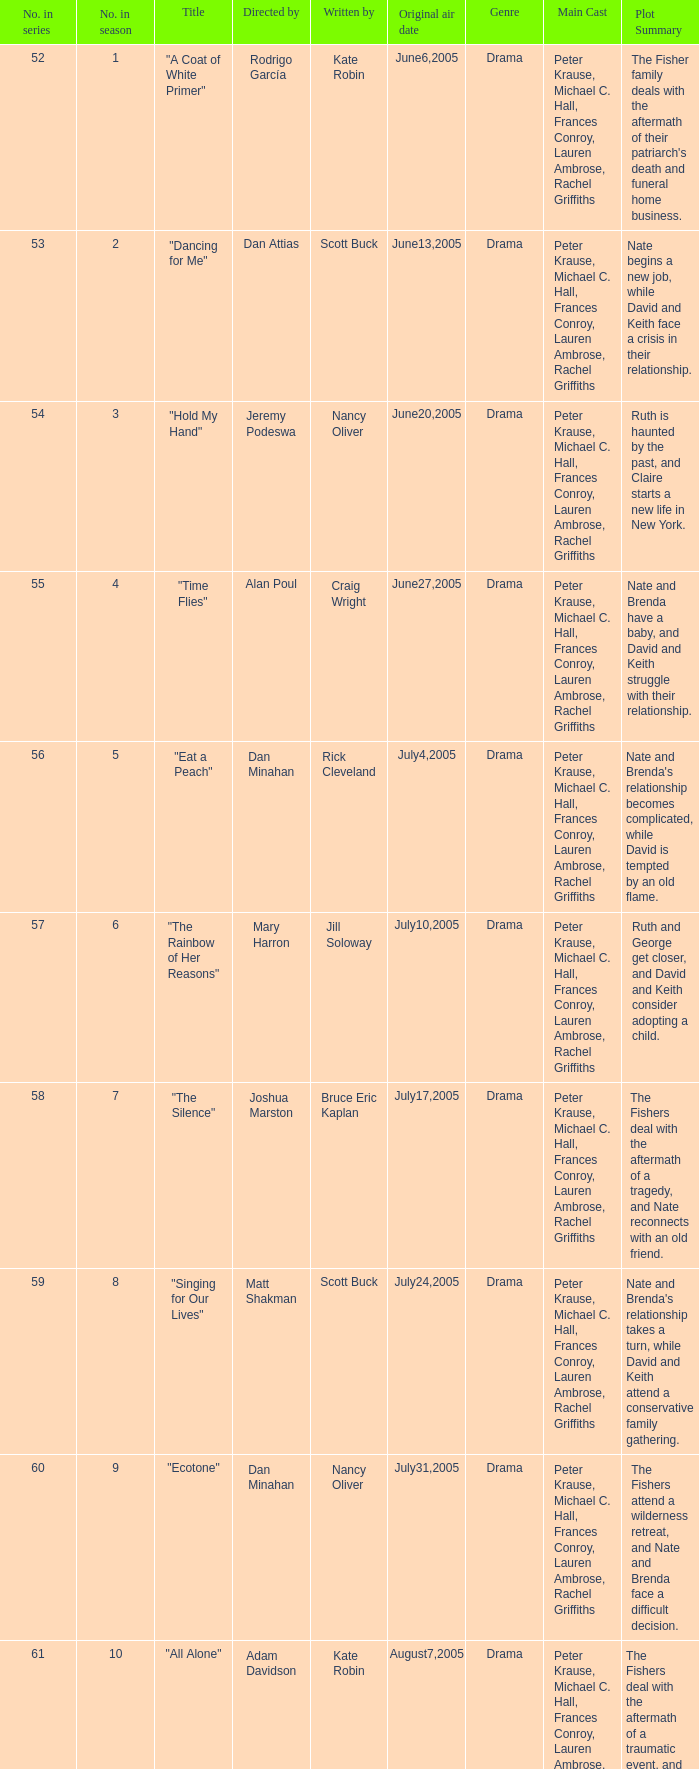Parse the full table. {'header': ['No. in series', 'No. in season', 'Title', 'Directed by', 'Written by', 'Original air date', 'Genre', 'Main Cast', 'Plot Summary '], 'rows': [['52', '1', '"A Coat of White Primer"', 'Rodrigo García', 'Kate Robin', 'June6,2005', 'Drama', 'Peter Krause, Michael C. Hall, Frances Conroy, Lauren Ambrose, Rachel Griffiths', "The Fisher family deals with the aftermath of their patriarch's death and funeral home business. "], ['53', '2', '"Dancing for Me"', 'Dan Attias', 'Scott Buck', 'June13,2005', 'Drama', 'Peter Krause, Michael C. Hall, Frances Conroy, Lauren Ambrose, Rachel Griffiths', 'Nate begins a new job, while David and Keith face a crisis in their relationship. '], ['54', '3', '"Hold My Hand"', 'Jeremy Podeswa', 'Nancy Oliver', 'June20,2005', 'Drama', 'Peter Krause, Michael C. Hall, Frances Conroy, Lauren Ambrose, Rachel Griffiths', 'Ruth is haunted by the past, and Claire starts a new life in New York. '], ['55', '4', '"Time Flies"', 'Alan Poul', 'Craig Wright', 'June27,2005', 'Drama', 'Peter Krause, Michael C. Hall, Frances Conroy, Lauren Ambrose, Rachel Griffiths', 'Nate and Brenda have a baby, and David and Keith struggle with their relationship. '], ['56', '5', '"Eat a Peach"', 'Dan Minahan', 'Rick Cleveland', 'July4,2005', 'Drama', 'Peter Krause, Michael C. Hall, Frances Conroy, Lauren Ambrose, Rachel Griffiths', "Nate and Brenda's relationship becomes complicated, while David is tempted by an old flame. "], ['57', '6', '"The Rainbow of Her Reasons"', 'Mary Harron', 'Jill Soloway', 'July10,2005', 'Drama', 'Peter Krause, Michael C. Hall, Frances Conroy, Lauren Ambrose, Rachel Griffiths', 'Ruth and George get closer, and David and Keith consider adopting a child. '], ['58', '7', '"The Silence"', 'Joshua Marston', 'Bruce Eric Kaplan', 'July17,2005', 'Drama', 'Peter Krause, Michael C. Hall, Frances Conroy, Lauren Ambrose, Rachel Griffiths', 'The Fishers deal with the aftermath of a tragedy, and Nate reconnects with an old friend. '], ['59', '8', '"Singing for Our Lives"', 'Matt Shakman', 'Scott Buck', 'July24,2005', 'Drama', 'Peter Krause, Michael C. Hall, Frances Conroy, Lauren Ambrose, Rachel Griffiths', "Nate and Brenda's relationship takes a turn, while David and Keith attend a conservative family gathering. "], ['60', '9', '"Ecotone"', 'Dan Minahan', 'Nancy Oliver', 'July31,2005', 'Drama', 'Peter Krause, Michael C. Hall, Frances Conroy, Lauren Ambrose, Rachel Griffiths', 'The Fishers attend a wilderness retreat, and Nate and Brenda face a difficult decision. '], ['61', '10', '"All Alone"', 'Adam Davidson', 'Kate Robin', 'August7,2005', 'Drama', 'Peter Krause, Michael C. Hall, Frances Conroy, Lauren Ambrose, Rachel Griffiths', 'The Fishers deal with the aftermath of a traumatic event, and Nate and Brenda make a life-changing decision. '], ['62', '11', '"Static"', 'Michael Cuesta', 'Craig Wright', 'August14,2005', 'Drama', 'Peter Krause, Michael C. Hall, Frances Conroy, Lauren Ambrose, Rachel Griffiths', 'The Fishers face a crisis in the funeral home business, while Ruth considers her future.']]} What date was episode 10 in the season originally aired? August7,2005. 